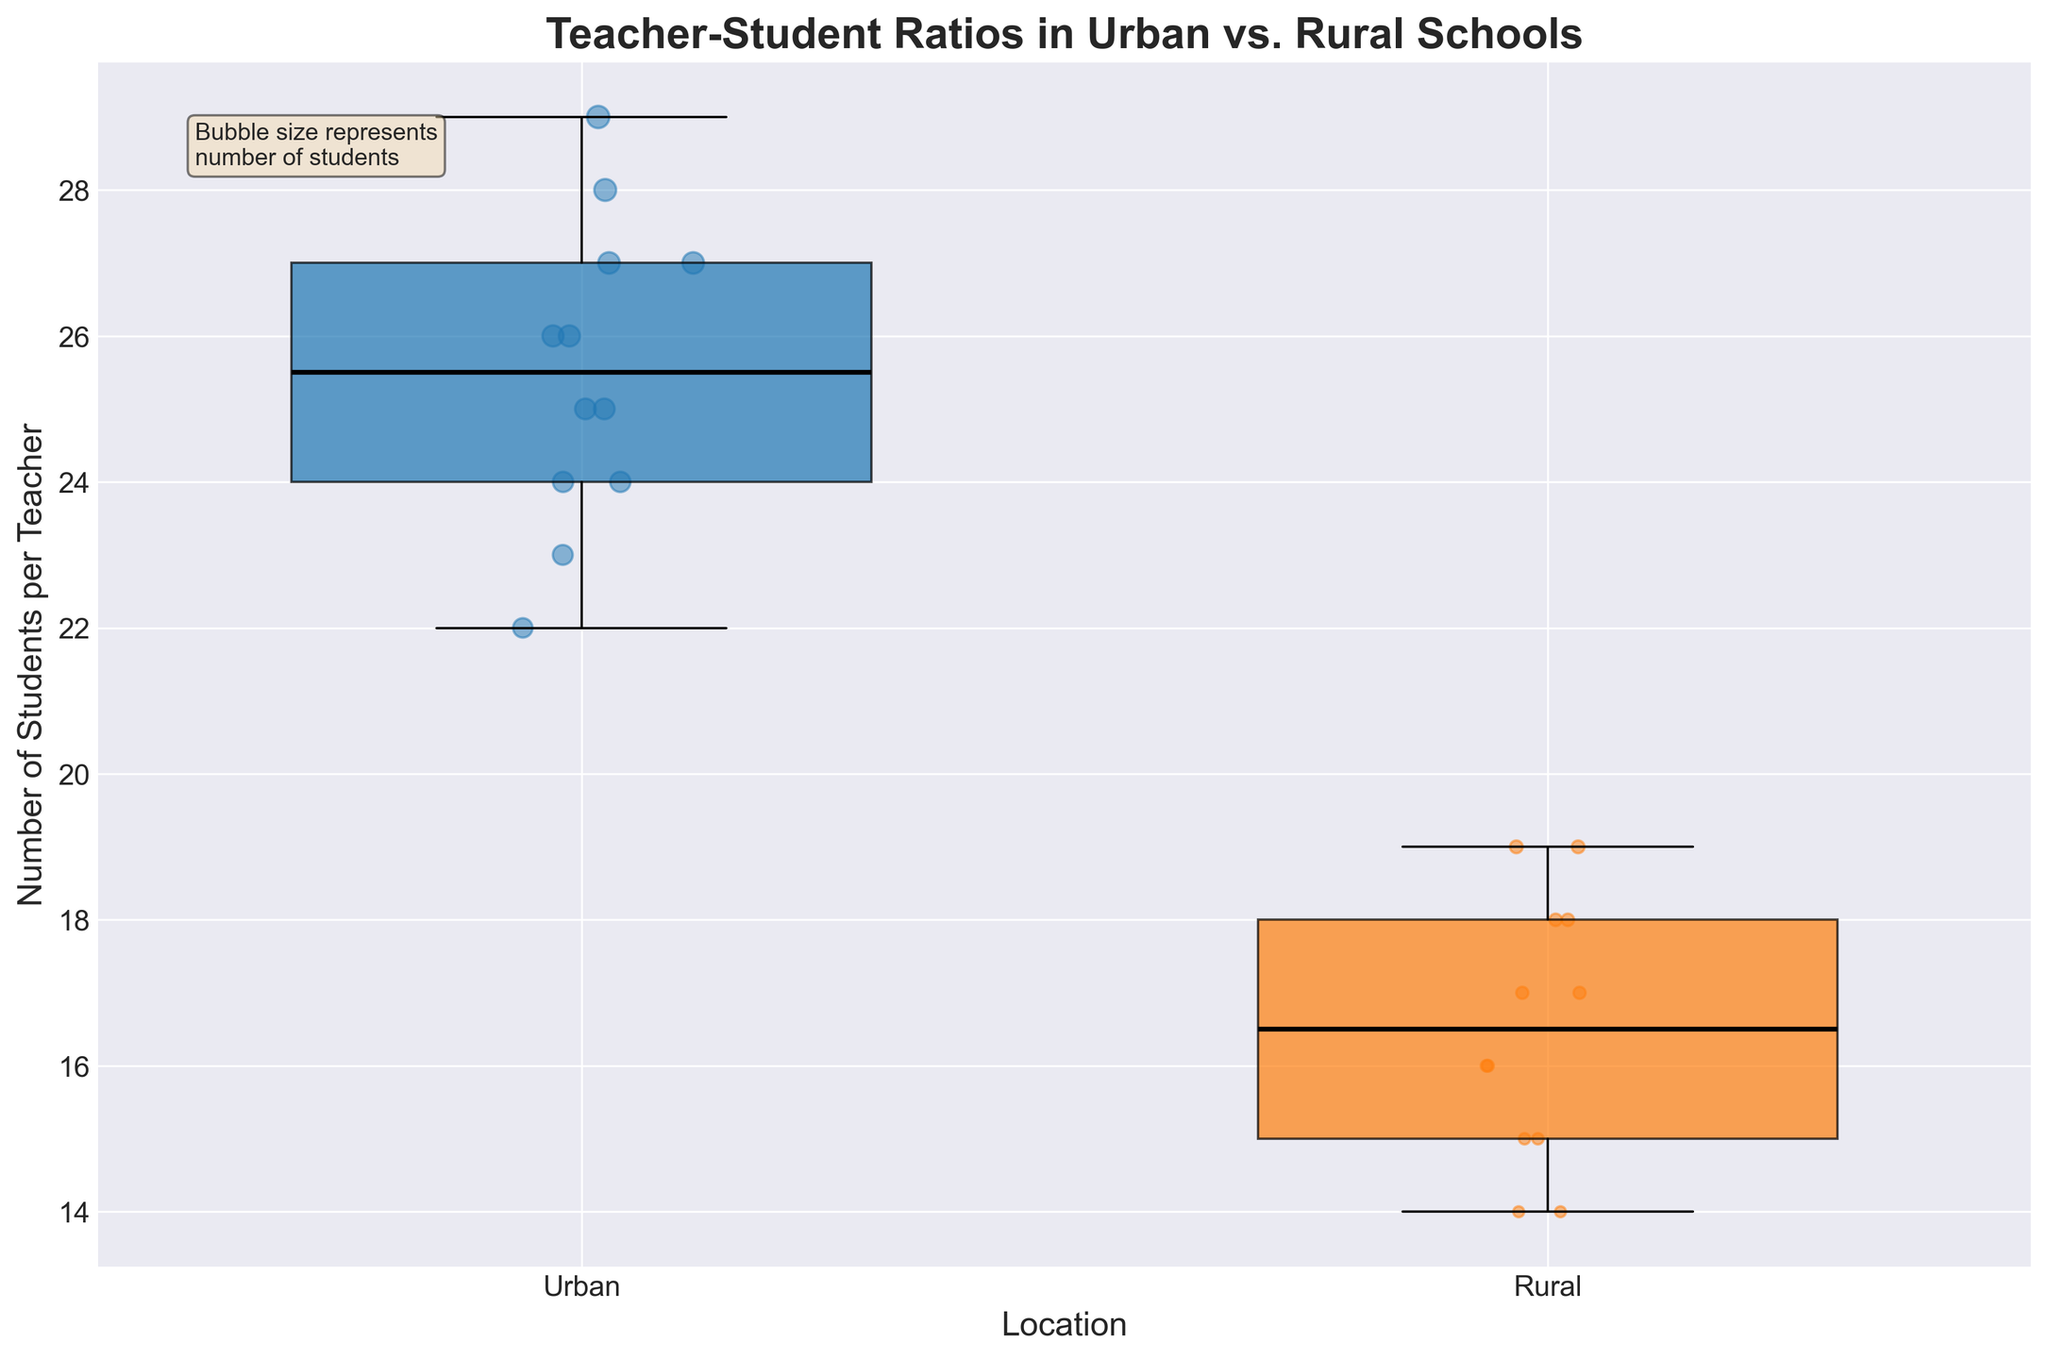What is the title of the plot? The title of the plot is displayed at the top and it reads "Teacher-Student Ratios in Urban vs. Rural Schools".
Answer: Teacher-Student Ratios in Urban vs. Rural Schools What are the labels on the x-axis? The x-axis labels are at the bottom of the plot and show the categories "Urban" and "Rural".
Answer: Urban, Rural Which location has a more varied teacher-student ratio? The box plot for the Urban schools shows a wider range and more outliers, indicating more variation compared to Rural schools.
Answer: Urban What is the median teacher-student ratio for Urban schools? The median teacher-student ratio is represented by the black line in the middle of the Urban box and is at 25.
Answer: 25 Are there any outliers in either location's teacher-student ratios? The plot has red diamond markers indicating outliers. There are outliers in both Urban and Rural school teacher-student ratios.
Answer: Yes Which location generally has smaller teacher-student ratios, Urban or Rural? The Rural schools box plot is lower on the y-axis, indicating smaller ratios compared to Urban schools.
Answer: Rural How does the bubble size relate to the data shown in the plot? The bubble size represents the number of students, as noted in the text annotation on the plot. Larger bubbles indicate more students.
Answer: Number of students What's the largest teacher-student ratio among Rural schools? The top edge of the Rural box plot represents the maximum teacher-student ratio, which is 19 students per teacher.
Answer: 19 Compare the average teacher-student ratios of Urban and Rural schools. The Urban teacher-student ratios are generally higher based on their box plot and scatter distribution, indicating a higher average compared to Rural schools.
Answer: Urban has higher ratios How do the sizes of the scatter points differ between Urban and Rural schools? The scatter points (bubbles) for Urban schools are generally larger, indicating a higher number of students compared to the smaller bubbles for Rural schools.
Answer: Urban bubbles are larger 